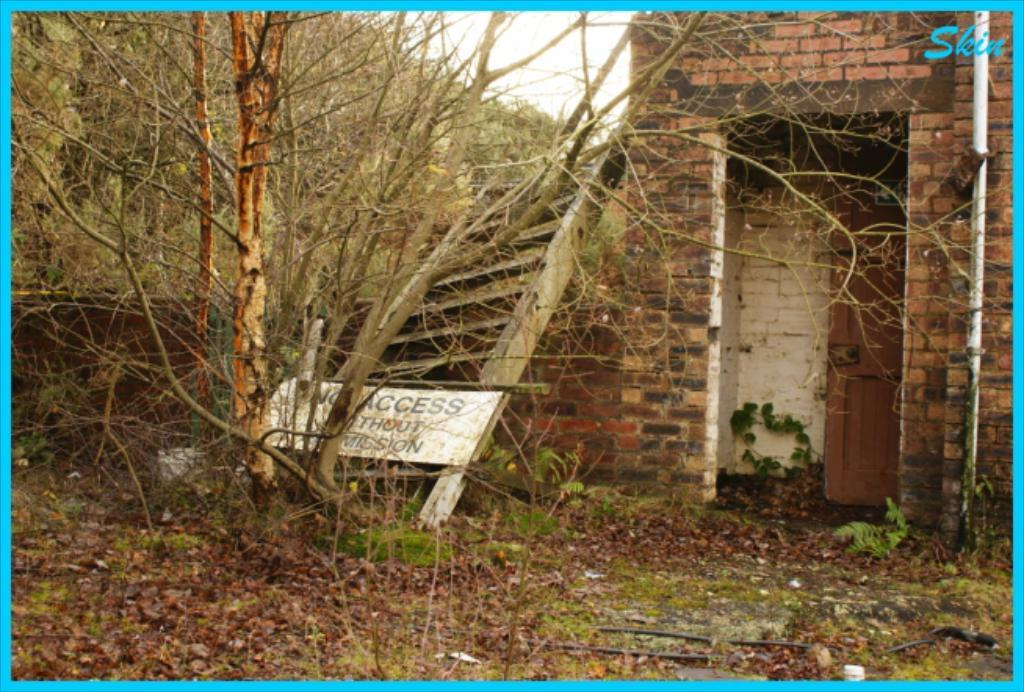Provide a one-sentence caption for the provided image. A sign with the words "No access" sits in front of an abandoned building. 